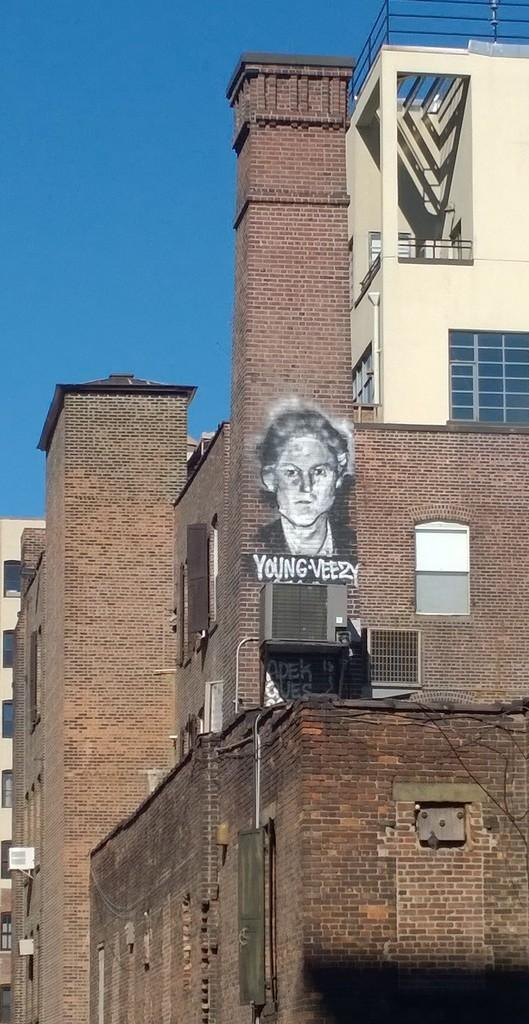What is the main feature in the center of the image? The center of the image contains the sky. What type of structures can be seen in the image? There are buildings in the image. What part of the buildings is visible in the image? Windows are visible in the image. What architectural element is present in the image? Railings are present in the image. Where is a painting located in the image? The painting is on a wall in the image. What is depicted in the painting? The painting depicts a person. Are there any words included in the painting? The painting includes some text. What type of ornament is hanging from the railings in the image? There is no ornament hanging from the railings in the image. What does the father in the painting say to the person depicted? There is no father or dialogue present in the painting; it only depicts a person and some text. 